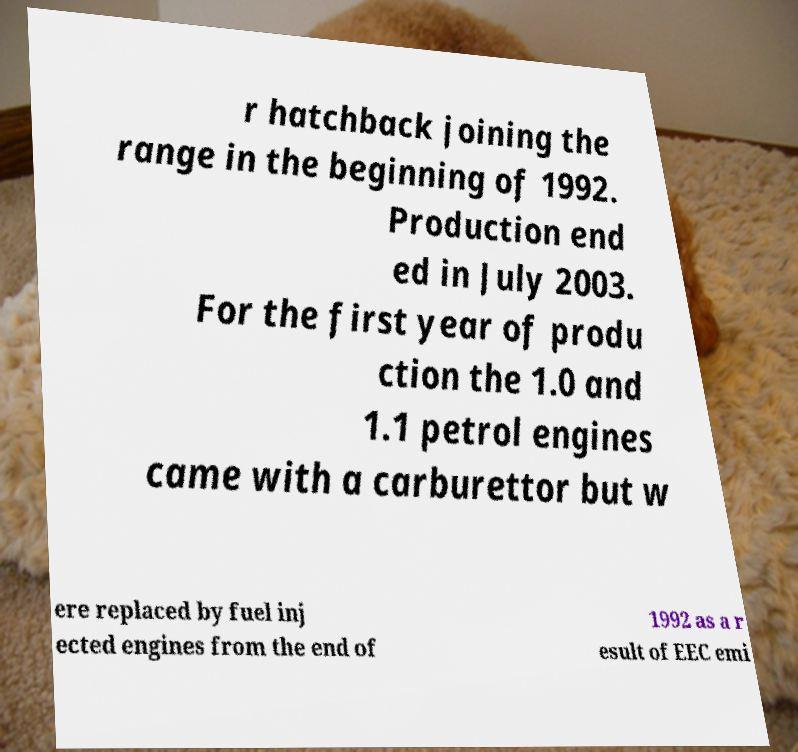I need the written content from this picture converted into text. Can you do that? r hatchback joining the range in the beginning of 1992. Production end ed in July 2003. For the first year of produ ction the 1.0 and 1.1 petrol engines came with a carburettor but w ere replaced by fuel inj ected engines from the end of 1992 as a r esult of EEC emi 